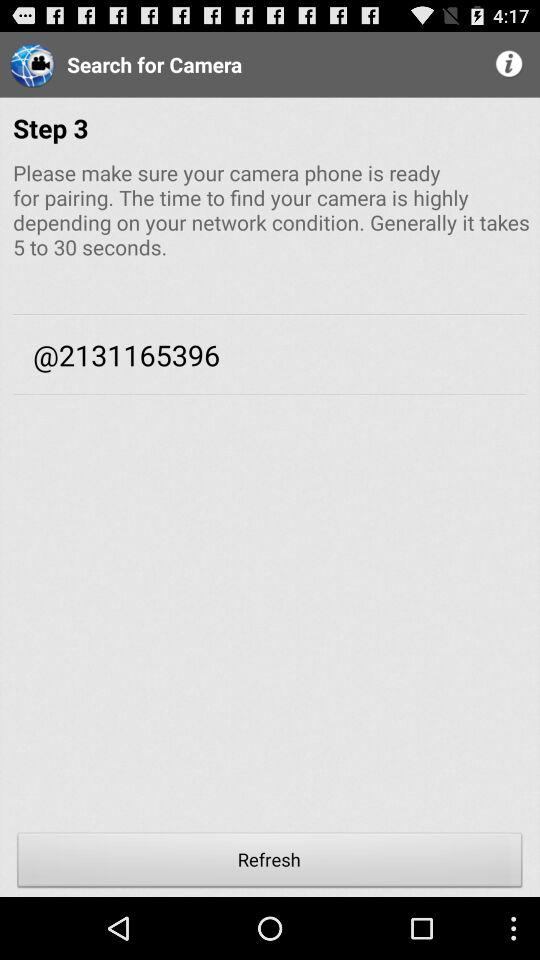At which step number are we? You are at step 3. 